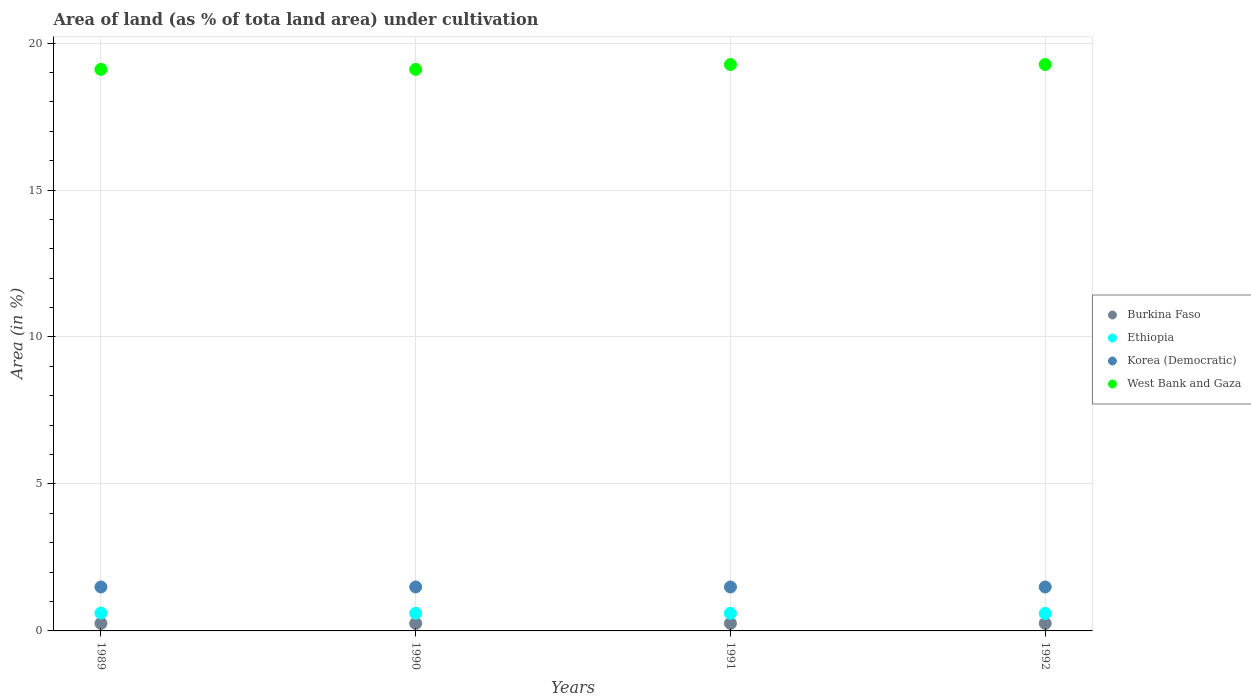How many different coloured dotlines are there?
Offer a terse response. 4. Is the number of dotlines equal to the number of legend labels?
Offer a terse response. Yes. What is the percentage of land under cultivation in Korea (Democratic) in 1990?
Give a very brief answer. 1.49. Across all years, what is the maximum percentage of land under cultivation in Korea (Democratic)?
Provide a short and direct response. 1.49. Across all years, what is the minimum percentage of land under cultivation in West Bank and Gaza?
Provide a short and direct response. 19.1. What is the total percentage of land under cultivation in Burkina Faso in the graph?
Ensure brevity in your answer.  1.02. What is the difference between the percentage of land under cultivation in Ethiopia in 1991 and the percentage of land under cultivation in Burkina Faso in 1989?
Make the answer very short. 0.34. What is the average percentage of land under cultivation in Korea (Democratic) per year?
Make the answer very short. 1.49. In the year 1991, what is the difference between the percentage of land under cultivation in Ethiopia and percentage of land under cultivation in Korea (Democratic)?
Provide a succinct answer. -0.9. In how many years, is the percentage of land under cultivation in Korea (Democratic) greater than the average percentage of land under cultivation in Korea (Democratic) taken over all years?
Your response must be concise. 0. Is it the case that in every year, the sum of the percentage of land under cultivation in Korea (Democratic) and percentage of land under cultivation in Ethiopia  is greater than the sum of percentage of land under cultivation in West Bank and Gaza and percentage of land under cultivation in Burkina Faso?
Your response must be concise. No. Does the percentage of land under cultivation in West Bank and Gaza monotonically increase over the years?
Make the answer very short. No. How many dotlines are there?
Offer a very short reply. 4. How many years are there in the graph?
Your answer should be very brief. 4. Does the graph contain any zero values?
Make the answer very short. No. Where does the legend appear in the graph?
Provide a succinct answer. Center right. How are the legend labels stacked?
Offer a very short reply. Vertical. What is the title of the graph?
Make the answer very short. Area of land (as % of tota land area) under cultivation. What is the label or title of the Y-axis?
Ensure brevity in your answer.  Area (in %). What is the Area (in %) of Burkina Faso in 1989?
Give a very brief answer. 0.26. What is the Area (in %) of Ethiopia in 1989?
Keep it short and to the point. 0.61. What is the Area (in %) in Korea (Democratic) in 1989?
Your answer should be very brief. 1.49. What is the Area (in %) of West Bank and Gaza in 1989?
Offer a terse response. 19.1. What is the Area (in %) of Burkina Faso in 1990?
Provide a succinct answer. 0.26. What is the Area (in %) of Ethiopia in 1990?
Give a very brief answer. 0.6. What is the Area (in %) of Korea (Democratic) in 1990?
Provide a succinct answer. 1.49. What is the Area (in %) of West Bank and Gaza in 1990?
Offer a terse response. 19.1. What is the Area (in %) in Burkina Faso in 1991?
Offer a very short reply. 0.26. What is the Area (in %) of Ethiopia in 1991?
Offer a terse response. 0.6. What is the Area (in %) of Korea (Democratic) in 1991?
Your answer should be compact. 1.49. What is the Area (in %) of West Bank and Gaza in 1991?
Keep it short and to the point. 19.27. What is the Area (in %) in Burkina Faso in 1992?
Ensure brevity in your answer.  0.26. What is the Area (in %) of Ethiopia in 1992?
Provide a succinct answer. 0.59. What is the Area (in %) in Korea (Democratic) in 1992?
Provide a succinct answer. 1.49. What is the Area (in %) in West Bank and Gaza in 1992?
Offer a very short reply. 19.27. Across all years, what is the maximum Area (in %) of Burkina Faso?
Ensure brevity in your answer.  0.26. Across all years, what is the maximum Area (in %) of Ethiopia?
Your answer should be very brief. 0.61. Across all years, what is the maximum Area (in %) of Korea (Democratic)?
Offer a very short reply. 1.49. Across all years, what is the maximum Area (in %) in West Bank and Gaza?
Ensure brevity in your answer.  19.27. Across all years, what is the minimum Area (in %) in Burkina Faso?
Ensure brevity in your answer.  0.26. Across all years, what is the minimum Area (in %) in Ethiopia?
Keep it short and to the point. 0.59. Across all years, what is the minimum Area (in %) in Korea (Democratic)?
Ensure brevity in your answer.  1.49. Across all years, what is the minimum Area (in %) in West Bank and Gaza?
Your response must be concise. 19.1. What is the total Area (in %) in Burkina Faso in the graph?
Offer a very short reply. 1.02. What is the total Area (in %) of Ethiopia in the graph?
Your response must be concise. 2.4. What is the total Area (in %) of Korea (Democratic) in the graph?
Your answer should be very brief. 5.98. What is the total Area (in %) of West Bank and Gaza in the graph?
Provide a succinct answer. 76.74. What is the difference between the Area (in %) of Ethiopia in 1989 and that in 1990?
Your response must be concise. 0.01. What is the difference between the Area (in %) in West Bank and Gaza in 1989 and that in 1990?
Your answer should be very brief. 0. What is the difference between the Area (in %) of Burkina Faso in 1989 and that in 1991?
Keep it short and to the point. 0. What is the difference between the Area (in %) of Ethiopia in 1989 and that in 1991?
Provide a succinct answer. 0.01. What is the difference between the Area (in %) of West Bank and Gaza in 1989 and that in 1991?
Your answer should be compact. -0.17. What is the difference between the Area (in %) in Ethiopia in 1989 and that in 1992?
Provide a succinct answer. 0.01. What is the difference between the Area (in %) of West Bank and Gaza in 1989 and that in 1992?
Your response must be concise. -0.17. What is the difference between the Area (in %) in Ethiopia in 1990 and that in 1991?
Ensure brevity in your answer.  0. What is the difference between the Area (in %) of Korea (Democratic) in 1990 and that in 1991?
Your answer should be very brief. 0. What is the difference between the Area (in %) of West Bank and Gaza in 1990 and that in 1991?
Make the answer very short. -0.17. What is the difference between the Area (in %) of Ethiopia in 1990 and that in 1992?
Keep it short and to the point. 0.01. What is the difference between the Area (in %) of Korea (Democratic) in 1990 and that in 1992?
Provide a succinct answer. 0. What is the difference between the Area (in %) in West Bank and Gaza in 1990 and that in 1992?
Your answer should be very brief. -0.17. What is the difference between the Area (in %) of Ethiopia in 1991 and that in 1992?
Give a very brief answer. 0. What is the difference between the Area (in %) in Korea (Democratic) in 1991 and that in 1992?
Offer a terse response. 0. What is the difference between the Area (in %) in Burkina Faso in 1989 and the Area (in %) in Ethiopia in 1990?
Keep it short and to the point. -0.35. What is the difference between the Area (in %) in Burkina Faso in 1989 and the Area (in %) in Korea (Democratic) in 1990?
Your answer should be very brief. -1.24. What is the difference between the Area (in %) of Burkina Faso in 1989 and the Area (in %) of West Bank and Gaza in 1990?
Keep it short and to the point. -18.85. What is the difference between the Area (in %) in Ethiopia in 1989 and the Area (in %) in Korea (Democratic) in 1990?
Offer a very short reply. -0.89. What is the difference between the Area (in %) in Ethiopia in 1989 and the Area (in %) in West Bank and Gaza in 1990?
Your response must be concise. -18.49. What is the difference between the Area (in %) in Korea (Democratic) in 1989 and the Area (in %) in West Bank and Gaza in 1990?
Give a very brief answer. -17.61. What is the difference between the Area (in %) of Burkina Faso in 1989 and the Area (in %) of Ethiopia in 1991?
Your answer should be very brief. -0.34. What is the difference between the Area (in %) of Burkina Faso in 1989 and the Area (in %) of Korea (Democratic) in 1991?
Your answer should be compact. -1.24. What is the difference between the Area (in %) in Burkina Faso in 1989 and the Area (in %) in West Bank and Gaza in 1991?
Your answer should be very brief. -19.01. What is the difference between the Area (in %) of Ethiopia in 1989 and the Area (in %) of Korea (Democratic) in 1991?
Give a very brief answer. -0.89. What is the difference between the Area (in %) of Ethiopia in 1989 and the Area (in %) of West Bank and Gaza in 1991?
Make the answer very short. -18.66. What is the difference between the Area (in %) of Korea (Democratic) in 1989 and the Area (in %) of West Bank and Gaza in 1991?
Your response must be concise. -17.77. What is the difference between the Area (in %) of Burkina Faso in 1989 and the Area (in %) of Ethiopia in 1992?
Your answer should be compact. -0.34. What is the difference between the Area (in %) of Burkina Faso in 1989 and the Area (in %) of Korea (Democratic) in 1992?
Your answer should be very brief. -1.24. What is the difference between the Area (in %) of Burkina Faso in 1989 and the Area (in %) of West Bank and Gaza in 1992?
Ensure brevity in your answer.  -19.01. What is the difference between the Area (in %) of Ethiopia in 1989 and the Area (in %) of Korea (Democratic) in 1992?
Your response must be concise. -0.89. What is the difference between the Area (in %) of Ethiopia in 1989 and the Area (in %) of West Bank and Gaza in 1992?
Make the answer very short. -18.66. What is the difference between the Area (in %) of Korea (Democratic) in 1989 and the Area (in %) of West Bank and Gaza in 1992?
Offer a very short reply. -17.77. What is the difference between the Area (in %) of Burkina Faso in 1990 and the Area (in %) of Ethiopia in 1991?
Make the answer very short. -0.34. What is the difference between the Area (in %) of Burkina Faso in 1990 and the Area (in %) of Korea (Democratic) in 1991?
Your response must be concise. -1.24. What is the difference between the Area (in %) of Burkina Faso in 1990 and the Area (in %) of West Bank and Gaza in 1991?
Make the answer very short. -19.01. What is the difference between the Area (in %) in Ethiopia in 1990 and the Area (in %) in Korea (Democratic) in 1991?
Provide a short and direct response. -0.89. What is the difference between the Area (in %) in Ethiopia in 1990 and the Area (in %) in West Bank and Gaza in 1991?
Your response must be concise. -18.67. What is the difference between the Area (in %) in Korea (Democratic) in 1990 and the Area (in %) in West Bank and Gaza in 1991?
Give a very brief answer. -17.77. What is the difference between the Area (in %) in Burkina Faso in 1990 and the Area (in %) in Ethiopia in 1992?
Make the answer very short. -0.34. What is the difference between the Area (in %) of Burkina Faso in 1990 and the Area (in %) of Korea (Democratic) in 1992?
Provide a succinct answer. -1.24. What is the difference between the Area (in %) in Burkina Faso in 1990 and the Area (in %) in West Bank and Gaza in 1992?
Offer a very short reply. -19.01. What is the difference between the Area (in %) of Ethiopia in 1990 and the Area (in %) of Korea (Democratic) in 1992?
Keep it short and to the point. -0.89. What is the difference between the Area (in %) of Ethiopia in 1990 and the Area (in %) of West Bank and Gaza in 1992?
Provide a succinct answer. -18.67. What is the difference between the Area (in %) of Korea (Democratic) in 1990 and the Area (in %) of West Bank and Gaza in 1992?
Ensure brevity in your answer.  -17.77. What is the difference between the Area (in %) of Burkina Faso in 1991 and the Area (in %) of Ethiopia in 1992?
Provide a succinct answer. -0.34. What is the difference between the Area (in %) of Burkina Faso in 1991 and the Area (in %) of Korea (Democratic) in 1992?
Your answer should be very brief. -1.24. What is the difference between the Area (in %) of Burkina Faso in 1991 and the Area (in %) of West Bank and Gaza in 1992?
Your answer should be compact. -19.01. What is the difference between the Area (in %) of Ethiopia in 1991 and the Area (in %) of Korea (Democratic) in 1992?
Your response must be concise. -0.9. What is the difference between the Area (in %) of Ethiopia in 1991 and the Area (in %) of West Bank and Gaza in 1992?
Keep it short and to the point. -18.67. What is the difference between the Area (in %) of Korea (Democratic) in 1991 and the Area (in %) of West Bank and Gaza in 1992?
Keep it short and to the point. -17.77. What is the average Area (in %) in Burkina Faso per year?
Provide a succinct answer. 0.26. What is the average Area (in %) of Ethiopia per year?
Your answer should be very brief. 0.6. What is the average Area (in %) of Korea (Democratic) per year?
Provide a short and direct response. 1.49. What is the average Area (in %) in West Bank and Gaza per year?
Offer a very short reply. 19.19. In the year 1989, what is the difference between the Area (in %) of Burkina Faso and Area (in %) of Ethiopia?
Offer a very short reply. -0.35. In the year 1989, what is the difference between the Area (in %) in Burkina Faso and Area (in %) in Korea (Democratic)?
Your response must be concise. -1.24. In the year 1989, what is the difference between the Area (in %) in Burkina Faso and Area (in %) in West Bank and Gaza?
Ensure brevity in your answer.  -18.85. In the year 1989, what is the difference between the Area (in %) in Ethiopia and Area (in %) in Korea (Democratic)?
Keep it short and to the point. -0.89. In the year 1989, what is the difference between the Area (in %) in Ethiopia and Area (in %) in West Bank and Gaza?
Offer a very short reply. -18.49. In the year 1989, what is the difference between the Area (in %) in Korea (Democratic) and Area (in %) in West Bank and Gaza?
Offer a terse response. -17.61. In the year 1990, what is the difference between the Area (in %) in Burkina Faso and Area (in %) in Ethiopia?
Provide a short and direct response. -0.35. In the year 1990, what is the difference between the Area (in %) of Burkina Faso and Area (in %) of Korea (Democratic)?
Provide a succinct answer. -1.24. In the year 1990, what is the difference between the Area (in %) of Burkina Faso and Area (in %) of West Bank and Gaza?
Offer a terse response. -18.85. In the year 1990, what is the difference between the Area (in %) of Ethiopia and Area (in %) of Korea (Democratic)?
Offer a very short reply. -0.89. In the year 1990, what is the difference between the Area (in %) in Ethiopia and Area (in %) in West Bank and Gaza?
Offer a terse response. -18.5. In the year 1990, what is the difference between the Area (in %) of Korea (Democratic) and Area (in %) of West Bank and Gaza?
Keep it short and to the point. -17.61. In the year 1991, what is the difference between the Area (in %) of Burkina Faso and Area (in %) of Ethiopia?
Provide a short and direct response. -0.34. In the year 1991, what is the difference between the Area (in %) of Burkina Faso and Area (in %) of Korea (Democratic)?
Ensure brevity in your answer.  -1.24. In the year 1991, what is the difference between the Area (in %) of Burkina Faso and Area (in %) of West Bank and Gaza?
Offer a terse response. -19.01. In the year 1991, what is the difference between the Area (in %) in Ethiopia and Area (in %) in Korea (Democratic)?
Make the answer very short. -0.9. In the year 1991, what is the difference between the Area (in %) of Ethiopia and Area (in %) of West Bank and Gaza?
Give a very brief answer. -18.67. In the year 1991, what is the difference between the Area (in %) of Korea (Democratic) and Area (in %) of West Bank and Gaza?
Give a very brief answer. -17.77. In the year 1992, what is the difference between the Area (in %) of Burkina Faso and Area (in %) of Ethiopia?
Make the answer very short. -0.34. In the year 1992, what is the difference between the Area (in %) of Burkina Faso and Area (in %) of Korea (Democratic)?
Your answer should be compact. -1.24. In the year 1992, what is the difference between the Area (in %) in Burkina Faso and Area (in %) in West Bank and Gaza?
Your answer should be very brief. -19.01. In the year 1992, what is the difference between the Area (in %) of Ethiopia and Area (in %) of West Bank and Gaza?
Your answer should be compact. -18.67. In the year 1992, what is the difference between the Area (in %) in Korea (Democratic) and Area (in %) in West Bank and Gaza?
Make the answer very short. -17.77. What is the ratio of the Area (in %) of Burkina Faso in 1989 to that in 1990?
Make the answer very short. 1. What is the ratio of the Area (in %) of Ethiopia in 1989 to that in 1990?
Ensure brevity in your answer.  1.01. What is the ratio of the Area (in %) of West Bank and Gaza in 1989 to that in 1990?
Give a very brief answer. 1. What is the ratio of the Area (in %) of Ethiopia in 1989 to that in 1991?
Offer a very short reply. 1.02. What is the ratio of the Area (in %) of Korea (Democratic) in 1989 to that in 1991?
Offer a very short reply. 1. What is the ratio of the Area (in %) in Ethiopia in 1989 to that in 1992?
Offer a very short reply. 1.02. What is the ratio of the Area (in %) of Korea (Democratic) in 1989 to that in 1992?
Ensure brevity in your answer.  1. What is the ratio of the Area (in %) of West Bank and Gaza in 1989 to that in 1992?
Your answer should be compact. 0.99. What is the ratio of the Area (in %) of Burkina Faso in 1990 to that in 1991?
Ensure brevity in your answer.  1. What is the ratio of the Area (in %) of Korea (Democratic) in 1990 to that in 1991?
Make the answer very short. 1. What is the ratio of the Area (in %) of West Bank and Gaza in 1990 to that in 1991?
Give a very brief answer. 0.99. What is the ratio of the Area (in %) of Burkina Faso in 1990 to that in 1992?
Offer a terse response. 1. What is the ratio of the Area (in %) of Ethiopia in 1990 to that in 1992?
Ensure brevity in your answer.  1.01. What is the ratio of the Area (in %) of Korea (Democratic) in 1990 to that in 1992?
Offer a terse response. 1. What is the ratio of the Area (in %) of West Bank and Gaza in 1990 to that in 1992?
Offer a very short reply. 0.99. What is the ratio of the Area (in %) in Ethiopia in 1991 to that in 1992?
Offer a very short reply. 1. What is the ratio of the Area (in %) of Korea (Democratic) in 1991 to that in 1992?
Provide a succinct answer. 1. What is the ratio of the Area (in %) of West Bank and Gaza in 1991 to that in 1992?
Ensure brevity in your answer.  1. What is the difference between the highest and the second highest Area (in %) of Burkina Faso?
Provide a short and direct response. 0. What is the difference between the highest and the second highest Area (in %) in Ethiopia?
Offer a terse response. 0.01. What is the difference between the highest and the second highest Area (in %) in Korea (Democratic)?
Your answer should be very brief. 0. What is the difference between the highest and the second highest Area (in %) in West Bank and Gaza?
Provide a succinct answer. 0. What is the difference between the highest and the lowest Area (in %) in Burkina Faso?
Provide a succinct answer. 0. What is the difference between the highest and the lowest Area (in %) of Ethiopia?
Provide a short and direct response. 0.01. What is the difference between the highest and the lowest Area (in %) in Korea (Democratic)?
Offer a terse response. 0. What is the difference between the highest and the lowest Area (in %) in West Bank and Gaza?
Provide a succinct answer. 0.17. 